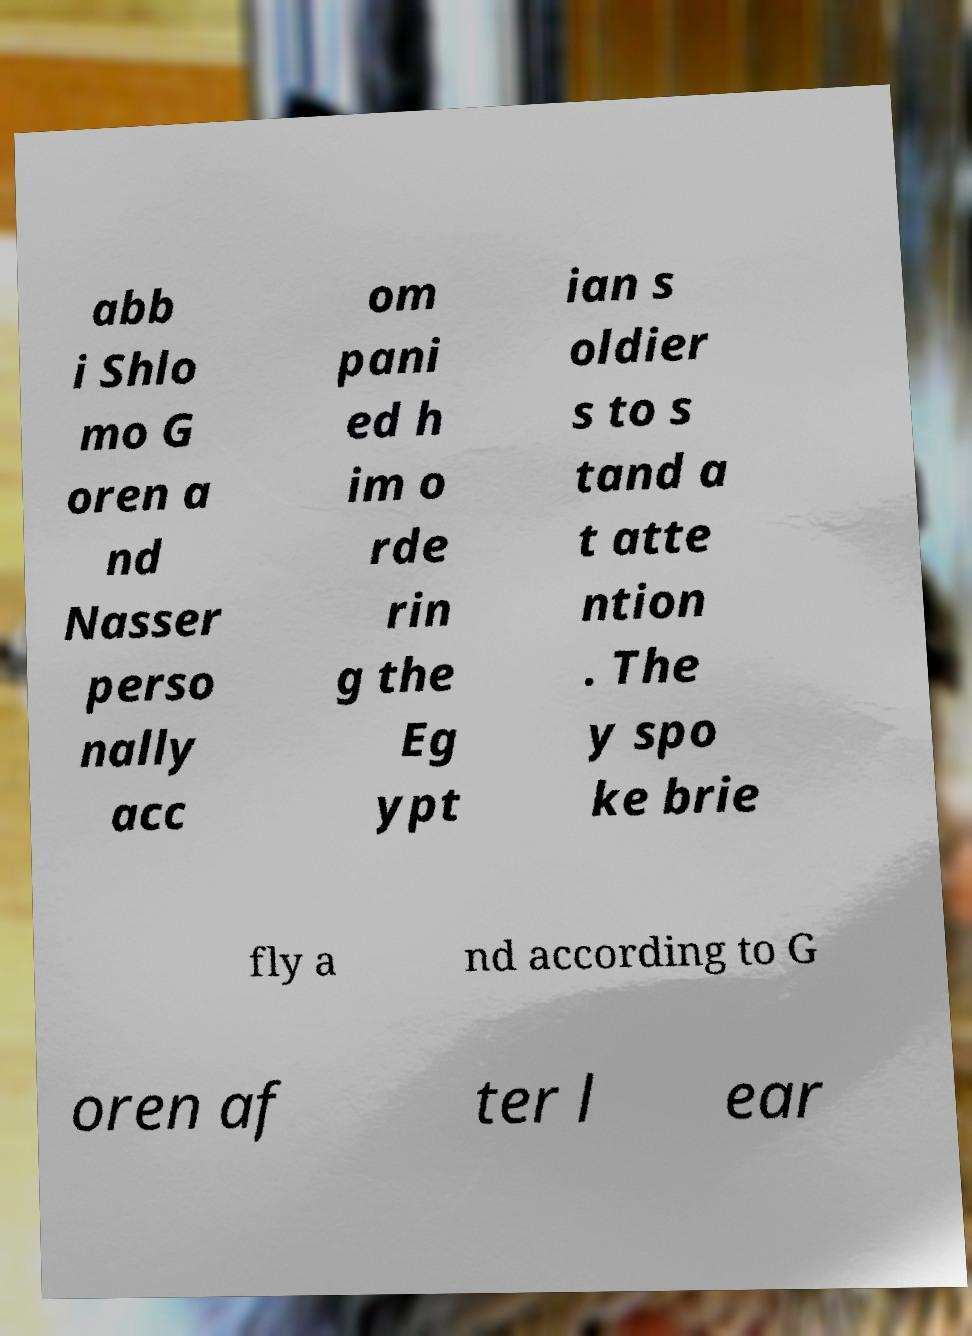For documentation purposes, I need the text within this image transcribed. Could you provide that? abb i Shlo mo G oren a nd Nasser perso nally acc om pani ed h im o rde rin g the Eg ypt ian s oldier s to s tand a t atte ntion . The y spo ke brie fly a nd according to G oren af ter l ear 